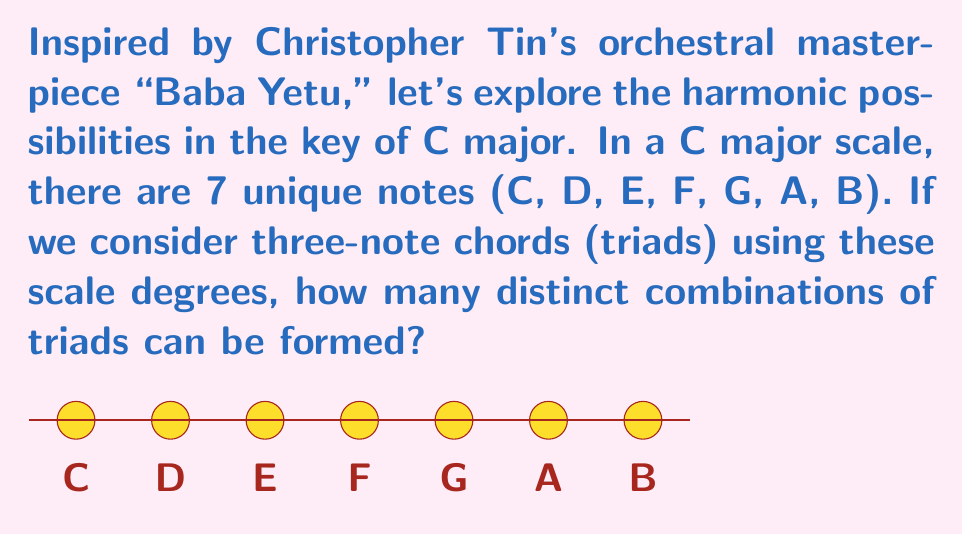Could you help me with this problem? Let's approach this step-by-step:

1) We are looking for combinations, not permutations, because the order of notes in a chord doesn't matter (e.g., C-E-G is the same chord as E-G-C).

2) We can use the combination formula:

   $$C(n,r) = \frac{n!}{r!(n-r)!}$$

   Where $n$ is the total number of items to choose from, and $r$ is the number of items being chosen.

3) In this case:
   $n = 7$ (total number of notes in the C major scale)
   $r = 3$ (we're forming triads, which are three-note chords)

4) Plugging these values into our formula:

   $$C(7,3) = \frac{7!}{3!(7-3)!} = \frac{7!}{3!4!}$$

5) Expanding this:
   $$\frac{7 \times 6 \times 5 \times 4!}{(3 \times 2 \times 1) \times 4!}$$

6) The $4!$ cancels out in the numerator and denominator:
   $$\frac{7 \times 6 \times 5}{3 \times 2 \times 1} = \frac{210}{6} = 35$$

Therefore, there are 35 distinct combinations of triads that can be formed using the notes of the C major scale.
Answer: 35 